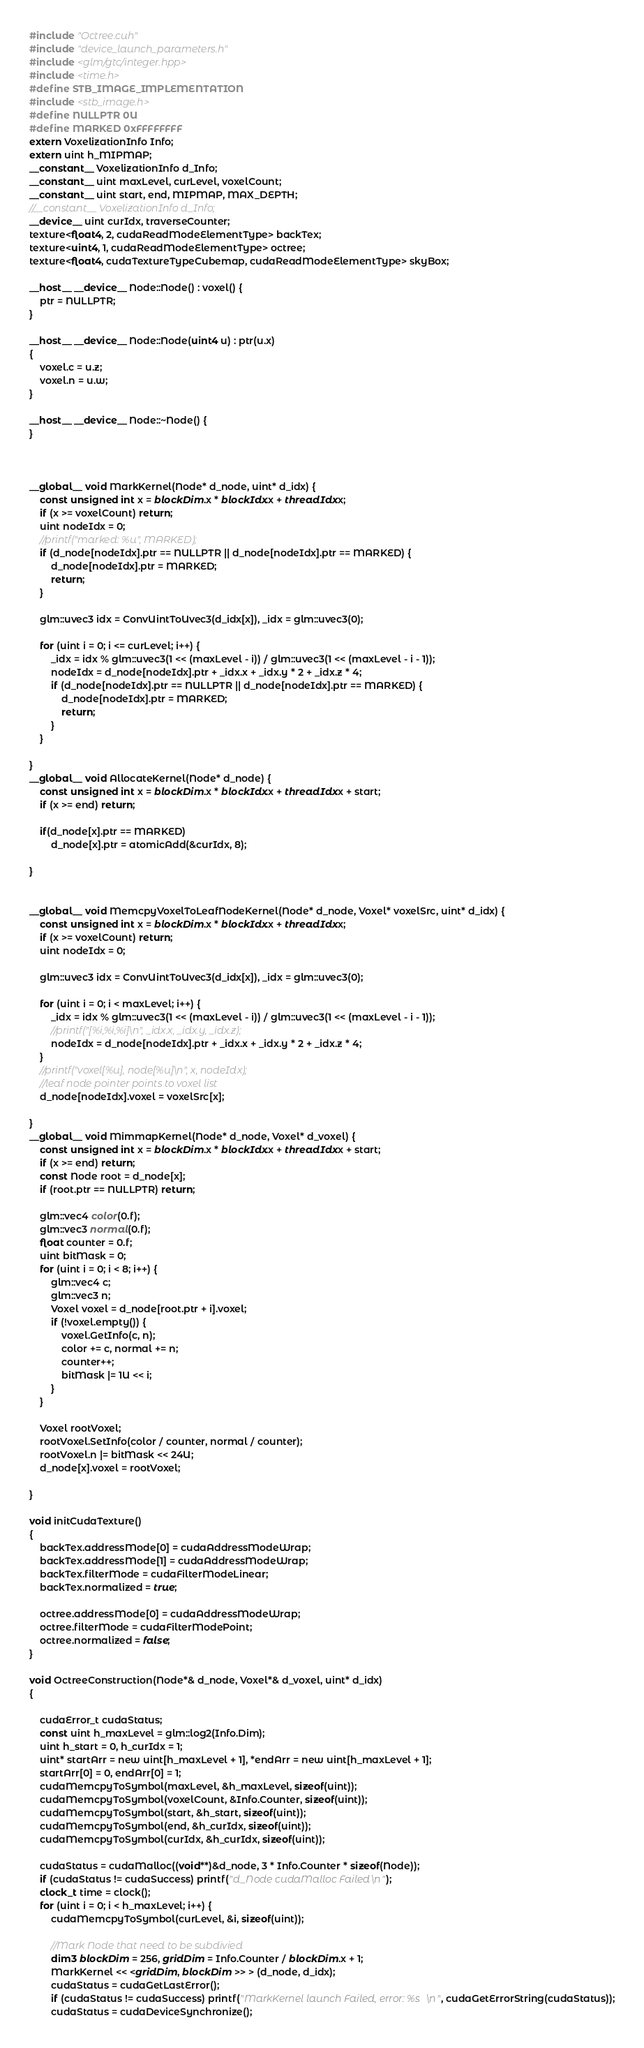<code> <loc_0><loc_0><loc_500><loc_500><_Cuda_>#include "Octree.cuh"
#include "device_launch_parameters.h"
#include <glm/gtc/integer.hpp>
#include <time.h>
#define STB_IMAGE_IMPLEMENTATION
#include <stb_image.h>
#define NULLPTR 0U
#define MARKED 0xFFFFFFFF
extern VoxelizationInfo Info;
extern uint h_MIPMAP;
__constant__ VoxelizationInfo d_Info;
__constant__ uint maxLevel, curLevel, voxelCount;
__constant__ uint start, end, MIPMAP, MAX_DEPTH;
//__constant__ VoxelizationInfo d_Info;
__device__ uint curIdx, traverseCounter;
texture<float4, 2, cudaReadModeElementType> backTex;
texture<uint4, 1, cudaReadModeElementType> octree;
texture<float4, cudaTextureTypeCubemap, cudaReadModeElementType> skyBox;

__host__ __device__ Node::Node() : voxel() {
	ptr = NULLPTR;
}

__host__ __device__ Node::Node(uint4 u) : ptr(u.x)
{
	voxel.c = u.z;
	voxel.n = u.w;
}

__host__ __device__ Node::~Node() {
}



__global__ void MarkKernel(Node* d_node, uint* d_idx) {
	const unsigned int x = blockDim.x * blockIdx.x + threadIdx.x;
	if (x >= voxelCount) return;
	uint nodeIdx = 0;
	//printf("marked: %u", MARKED);
	if (d_node[nodeIdx].ptr == NULLPTR || d_node[nodeIdx].ptr == MARKED) {
		d_node[nodeIdx].ptr = MARKED;
		return;
	}

	glm::uvec3 idx = ConvUintToUvec3(d_idx[x]), _idx = glm::uvec3(0);

	for (uint i = 0; i <= curLevel; i++) {
		_idx = idx % glm::uvec3(1 << (maxLevel - i)) / glm::uvec3(1 << (maxLevel - i - 1));
		nodeIdx = d_node[nodeIdx].ptr + _idx.x + _idx.y * 2 + _idx.z * 4;
		if (d_node[nodeIdx].ptr == NULLPTR || d_node[nodeIdx].ptr == MARKED) {
			d_node[nodeIdx].ptr = MARKED;
			return;
		}
	}
	
}
__global__ void AllocateKernel(Node* d_node) {
	const unsigned int x = blockDim.x * blockIdx.x + threadIdx.x + start;
	if (x >= end) return;

	if(d_node[x].ptr == MARKED)
		d_node[x].ptr = atomicAdd(&curIdx, 8);

}


__global__ void MemcpyVoxelToLeafNodeKernel(Node* d_node, Voxel* voxelSrc, uint* d_idx) {
	const unsigned int x = blockDim.x * blockIdx.x + threadIdx.x;
	if (x >= voxelCount) return;
	uint nodeIdx = 0;

	glm::uvec3 idx = ConvUintToUvec3(d_idx[x]), _idx = glm::uvec3(0);

	for (uint i = 0; i < maxLevel; i++) {
		_idx = idx % glm::uvec3(1 << (maxLevel - i)) / glm::uvec3(1 << (maxLevel - i - 1));
		//printf("[%i,%i,%i]\n", _idx.x, _idx.y, _idx.z);
		nodeIdx = d_node[nodeIdx].ptr + _idx.x + _idx.y * 2 + _idx.z * 4;
	}
	//printf("voxel[%u], node[%u]\n", x, nodeIdx);
	//leaf node pointer points to voxel list
	d_node[nodeIdx].voxel = voxelSrc[x];

}
__global__ void MimmapKernel(Node* d_node, Voxel* d_voxel) {
	const unsigned int x = blockDim.x * blockIdx.x + threadIdx.x + start;
	if (x >= end) return;
	const Node root = d_node[x];
	if (root.ptr == NULLPTR) return;

	glm::vec4 color(0.f);
	glm::vec3 normal(0.f);
	float counter = 0.f;
	uint bitMask = 0;
	for (uint i = 0; i < 8; i++) {
		glm::vec4 c;
		glm::vec3 n;
		Voxel voxel = d_node[root.ptr + i].voxel;
		if (!voxel.empty()) {
			voxel.GetInfo(c, n);
			color += c, normal += n;
			counter++;
			bitMask |= 1U << i;
		}
	}
	
	Voxel rootVoxel;
	rootVoxel.SetInfo(color / counter, normal / counter);
	rootVoxel.n |= bitMask << 24U;
	d_node[x].voxel = rootVoxel;

}

void initCudaTexture()
{
	backTex.addressMode[0] = cudaAddressModeWrap;
	backTex.addressMode[1] = cudaAddressModeWrap;
	backTex.filterMode = cudaFilterModeLinear;
	backTex.normalized = true;

	octree.addressMode[0] = cudaAddressModeWrap;
	octree.filterMode = cudaFilterModePoint;
	octree.normalized = false;
}

void OctreeConstruction(Node*& d_node, Voxel*& d_voxel, uint* d_idx)
{
	
	cudaError_t cudaStatus;
	const uint h_maxLevel = glm::log2(Info.Dim);
	uint h_start = 0, h_curIdx = 1;
	uint* startArr = new uint[h_maxLevel + 1], *endArr = new uint[h_maxLevel + 1];
	startArr[0] = 0, endArr[0] = 1;
	cudaMemcpyToSymbol(maxLevel, &h_maxLevel, sizeof(uint));
	cudaMemcpyToSymbol(voxelCount, &Info.Counter, sizeof(uint));
	cudaMemcpyToSymbol(start, &h_start, sizeof(uint));
	cudaMemcpyToSymbol(end, &h_curIdx, sizeof(uint));
	cudaMemcpyToSymbol(curIdx, &h_curIdx, sizeof(uint));

	cudaStatus = cudaMalloc((void**)&d_node, 3 * Info.Counter * sizeof(Node));
	if (cudaStatus != cudaSuccess) printf("d_Node cudaMalloc Failed\n");
	clock_t time = clock();
	for (uint i = 0; i < h_maxLevel; i++) {
		cudaMemcpyToSymbol(curLevel, &i, sizeof(uint));

		//Mark Node that need to be subdivied
		dim3 blockDim = 256, gridDim = Info.Counter / blockDim.x + 1;
		MarkKernel << <gridDim, blockDim >> > (d_node, d_idx);
		cudaStatus = cudaGetLastError();
		if (cudaStatus != cudaSuccess) printf("MarkKernel launch Failed, error: %s\n", cudaGetErrorString(cudaStatus));
		cudaStatus = cudaDeviceSynchronize();</code> 